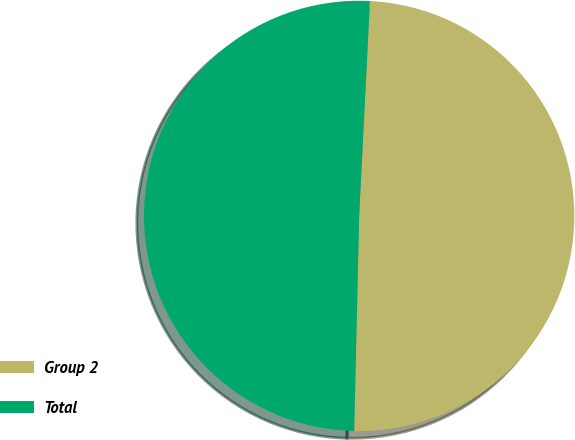<chart> <loc_0><loc_0><loc_500><loc_500><pie_chart><fcel>Group 2<fcel>Total<nl><fcel>49.57%<fcel>50.43%<nl></chart> 